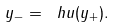Convert formula to latex. <formula><loc_0><loc_0><loc_500><loc_500>y _ { - } = \ h u ( y _ { + } ) .</formula> 